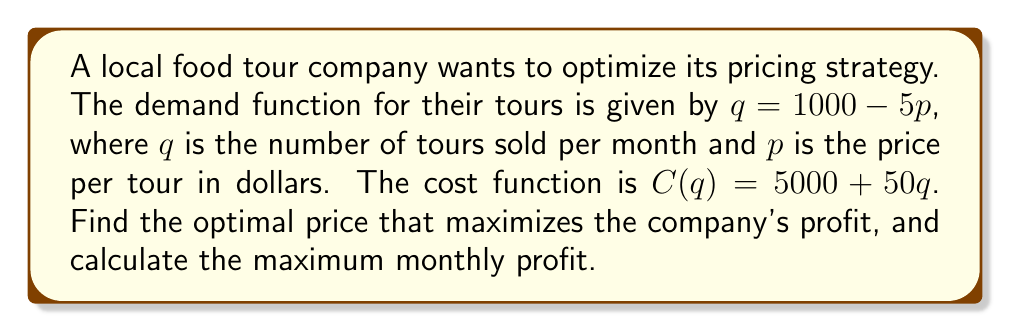Show me your answer to this math problem. 1. Let's start by defining the profit function. Profit is revenue minus cost:
   $P(q) = R(q) - C(q)$

2. Revenue is price times quantity: $R(q) = pq$
   We need to express $p$ in terms of $q$ using the demand function:
   $q = 1000 - 5p$
   $p = 200 - \frac{1}{5}q$

3. Now we can write the revenue function in terms of $q$:
   $R(q) = (200 - \frac{1}{5}q)q = 200q - \frac{1}{5}q^2$

4. The profit function becomes:
   $P(q) = (200q - \frac{1}{5}q^2) - (5000 + 50q)$
   $P(q) = -\frac{1}{5}q^2 + 150q - 5000$

5. To find the maximum profit, we differentiate $P(q)$ with respect to $q$ and set it to zero:
   $\frac{dP}{dq} = -\frac{2}{5}q + 150 = 0$
   $-\frac{2}{5}q = -150$
   $q = 375$

6. The second derivative is negative ($-\frac{2}{5}$), confirming this is a maximum.

7. Now we can find the optimal price using the demand function:
   $375 = 1000 - 5p$
   $5p = 625$
   $p = 125$

8. Calculate the maximum profit by substituting $q = 375$ into the profit function:
   $P(375) = -\frac{1}{5}(375)^2 + 150(375) - 5000$
   $= -28125 + 56250 - 5000$
   $= 23125$
Answer: Optimal price: $125; Maximum monthly profit: $23,125 